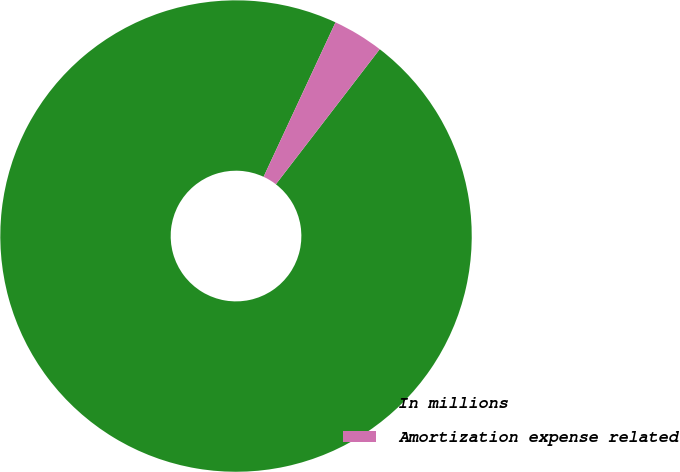Convert chart. <chart><loc_0><loc_0><loc_500><loc_500><pie_chart><fcel>In millions<fcel>Amortization expense related<nl><fcel>96.5%<fcel>3.5%<nl></chart> 